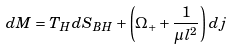Convert formula to latex. <formula><loc_0><loc_0><loc_500><loc_500>d M = T _ { H } d S _ { B H } + \left ( \Omega _ { + } + \frac { 1 } { \mu l ^ { 2 } } \right ) d j</formula> 